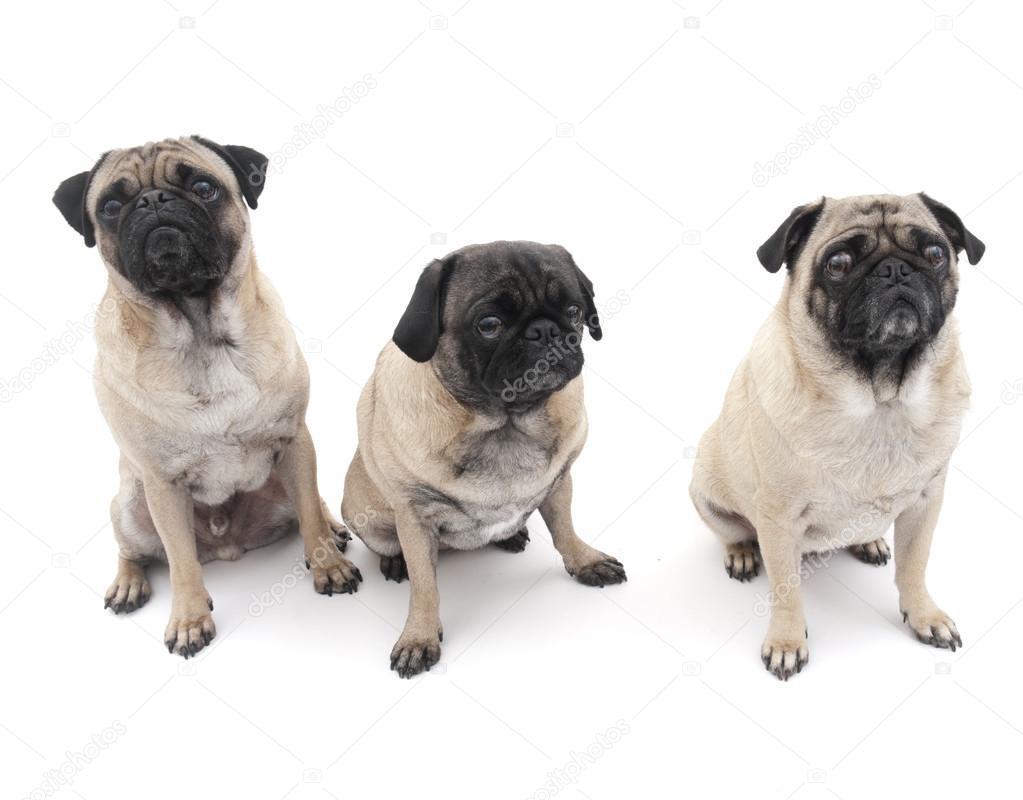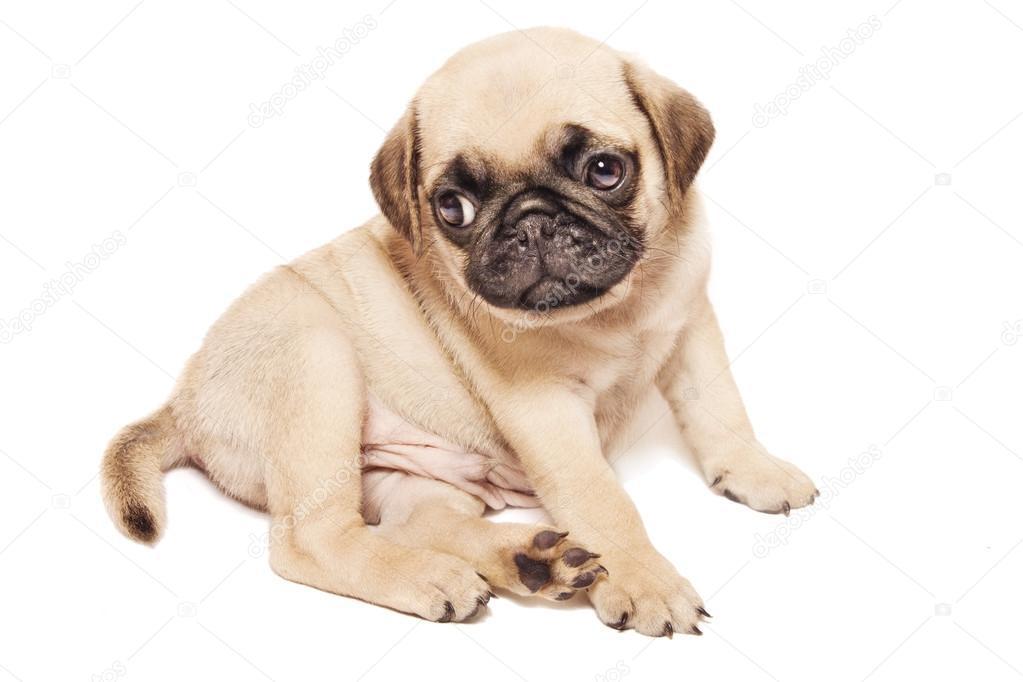The first image is the image on the left, the second image is the image on the right. Examine the images to the left and right. Is the description "Three dogs have their front paws off the ground." accurate? Answer yes or no. No. The first image is the image on the left, the second image is the image on the right. For the images shown, is this caption "One image shows a trio of pugs snoozing on a beige cushioned item, and the other image shows a row of three pugs, with paws draped on something white." true? Answer yes or no. No. 